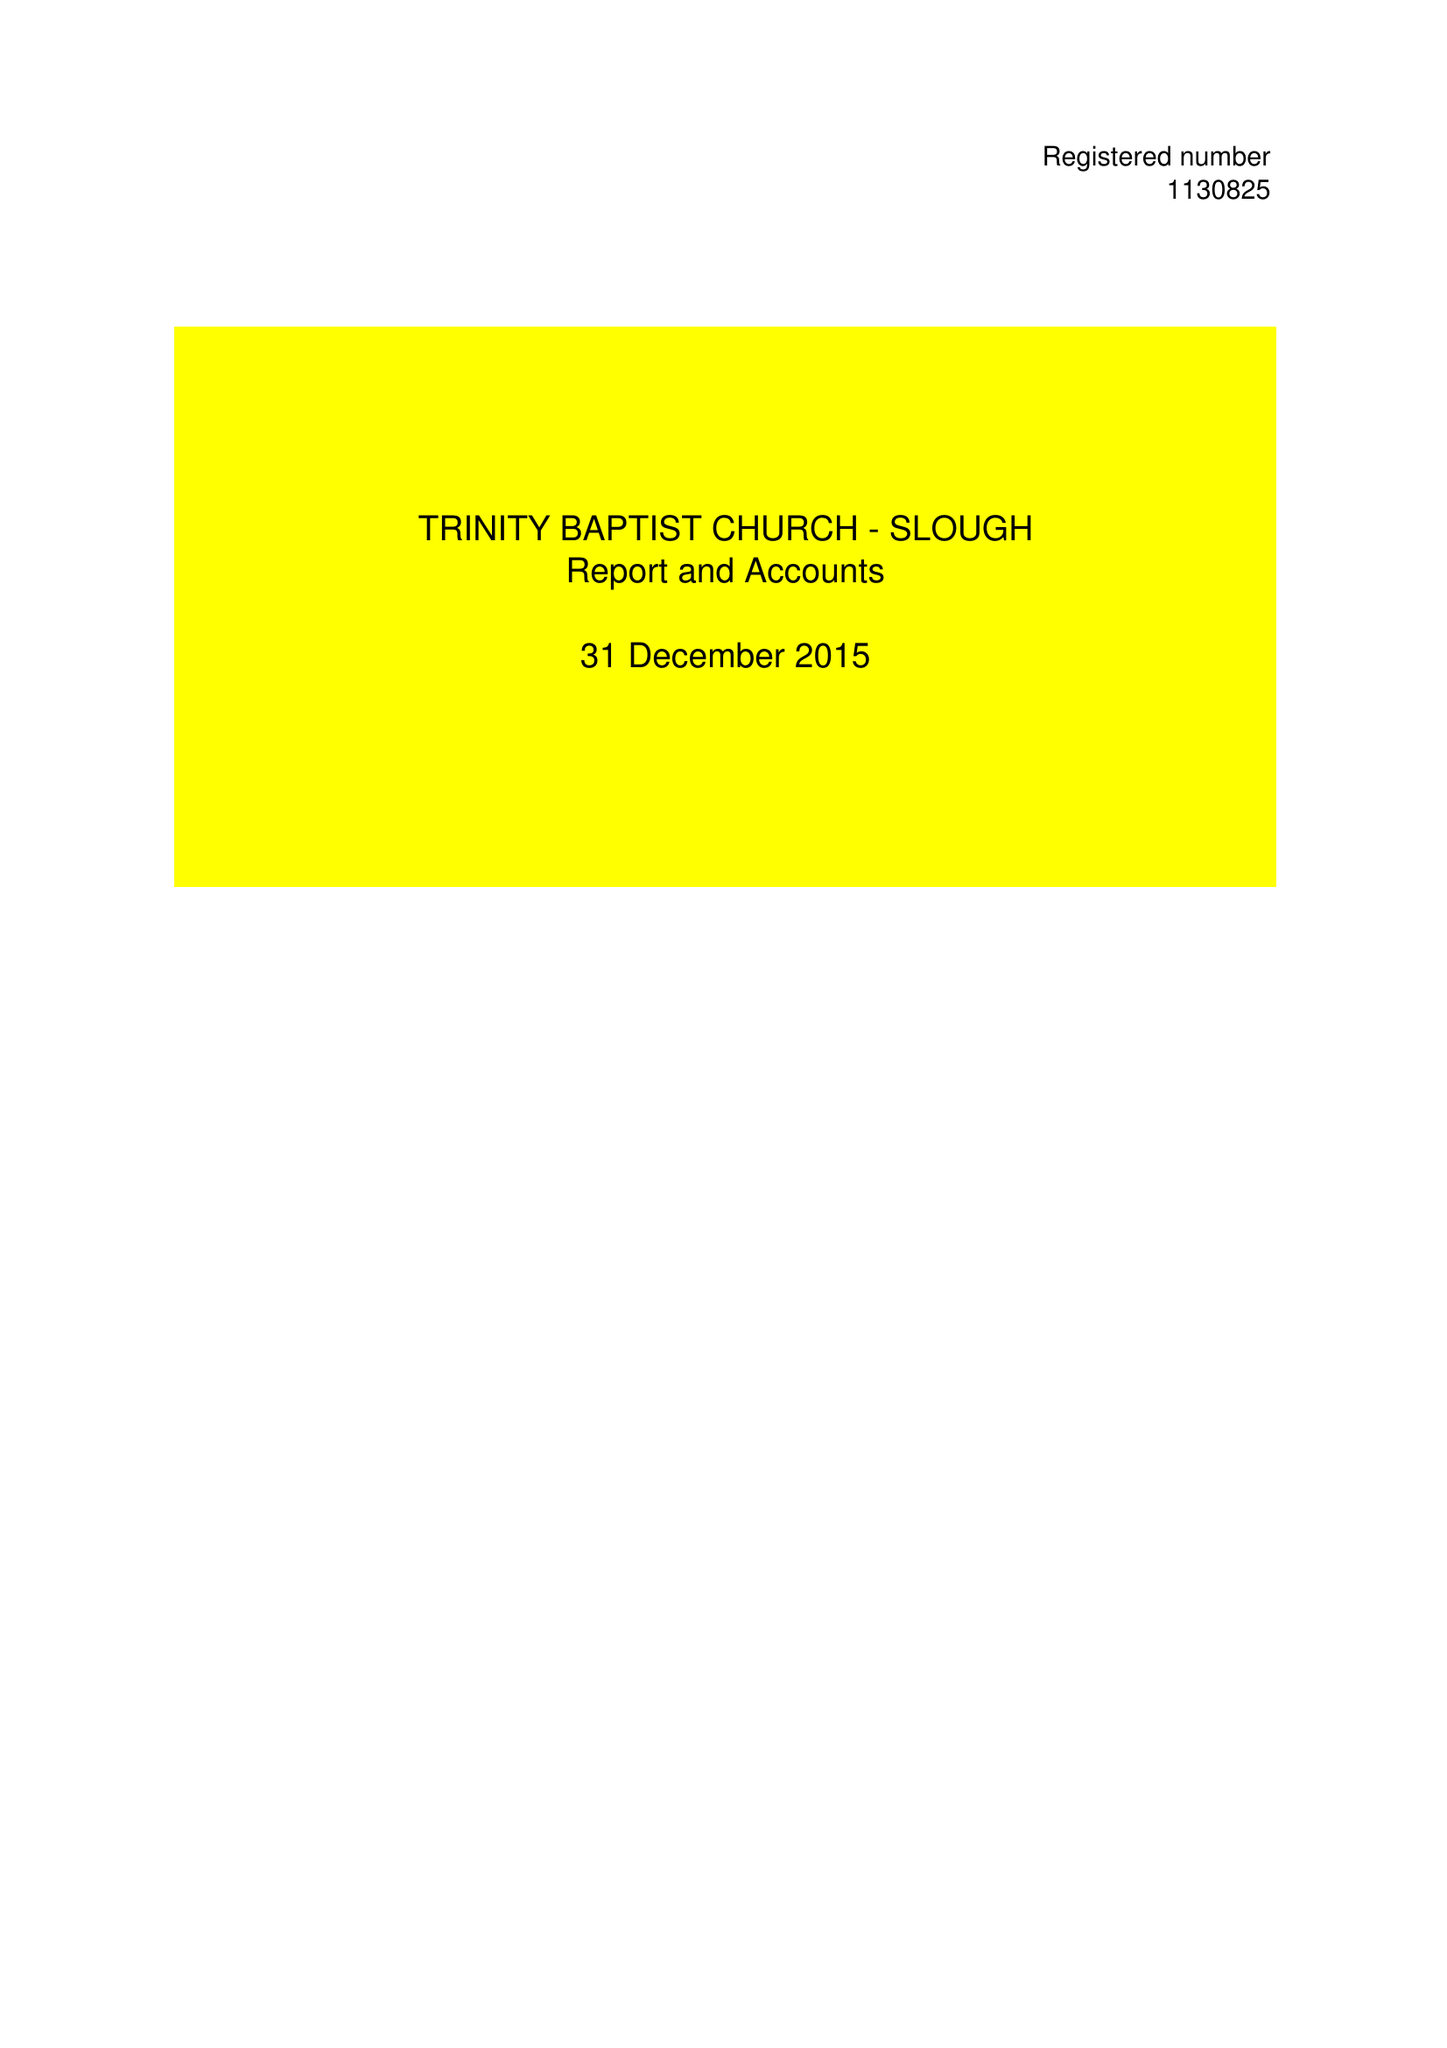What is the value for the report_date?
Answer the question using a single word or phrase. 2015-12-31 